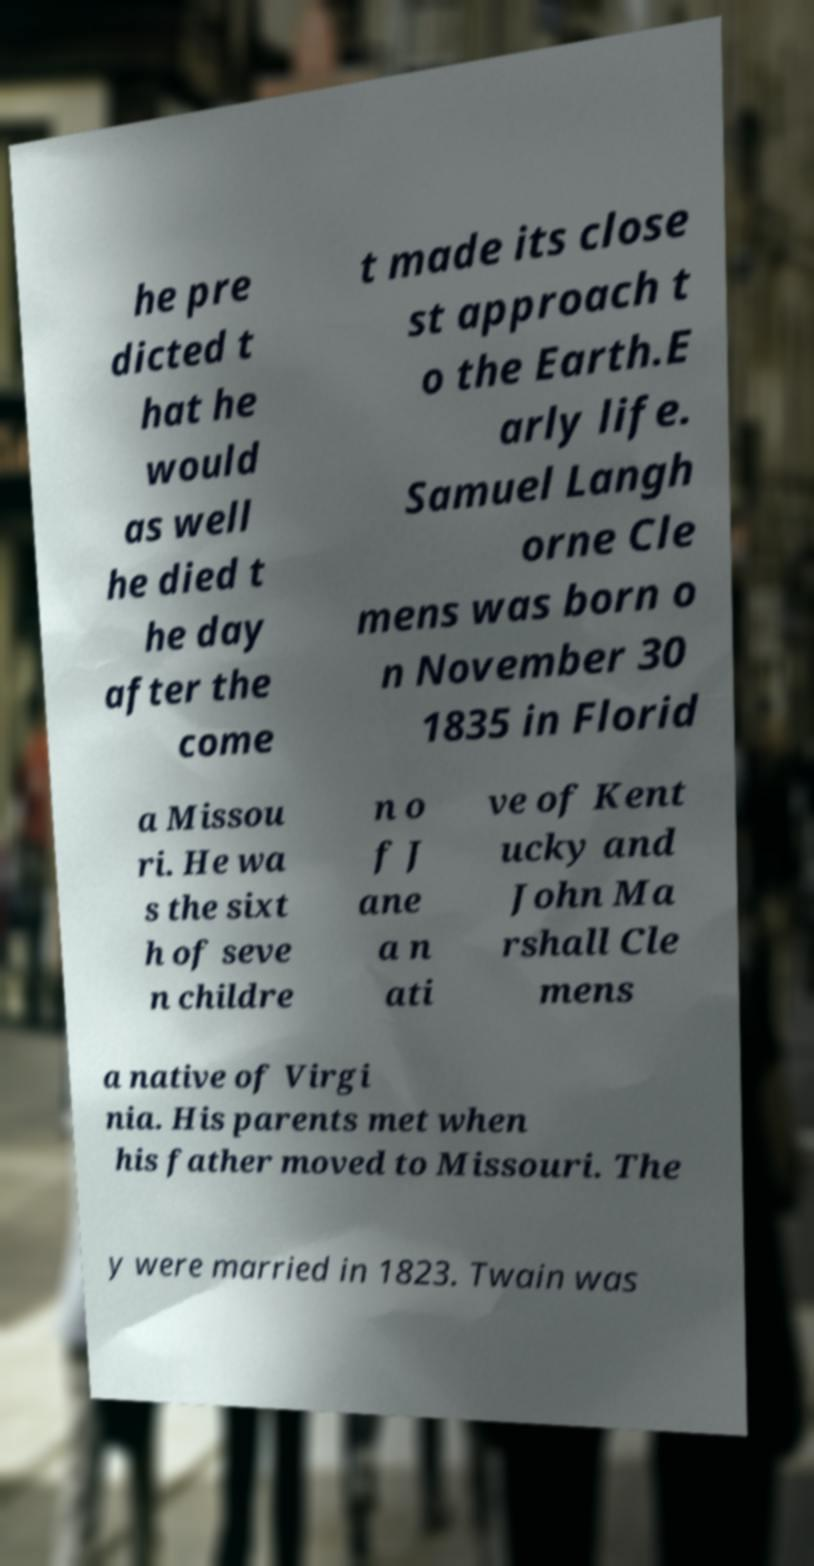Please read and relay the text visible in this image. What does it say? he pre dicted t hat he would as well he died t he day after the come t made its close st approach t o the Earth.E arly life. Samuel Langh orne Cle mens was born o n November 30 1835 in Florid a Missou ri. He wa s the sixt h of seve n childre n o f J ane a n ati ve of Kent ucky and John Ma rshall Cle mens a native of Virgi nia. His parents met when his father moved to Missouri. The y were married in 1823. Twain was 